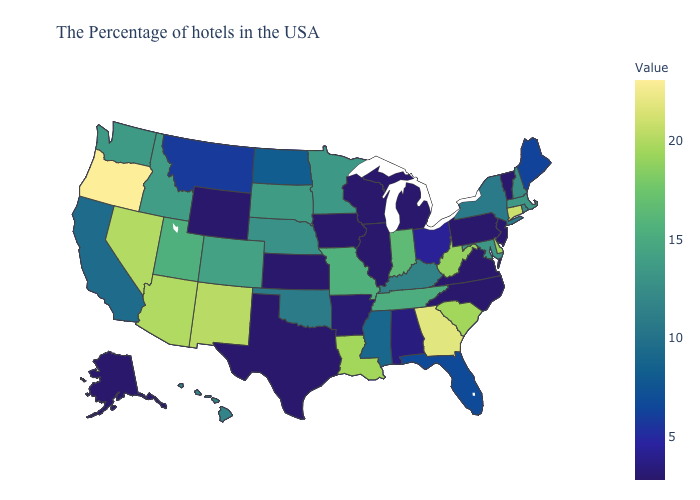Which states hav the highest value in the Northeast?
Be succinct. Connecticut. Does the map have missing data?
Concise answer only. No. 